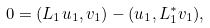<formula> <loc_0><loc_0><loc_500><loc_500>0 = ( L _ { 1 } u _ { 1 } , v _ { 1 } ) - ( u _ { 1 } , L _ { 1 } ^ { * } v _ { 1 } ) ,</formula> 